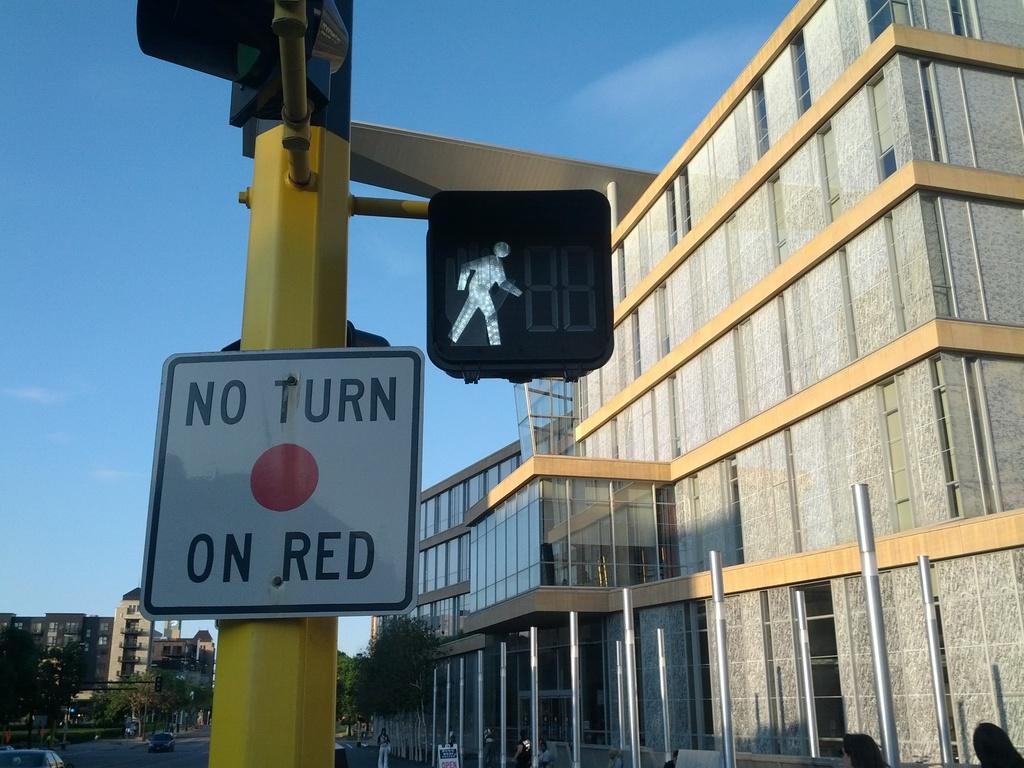What does the sign with the red circle indicate?
Give a very brief answer. No turn on red. 